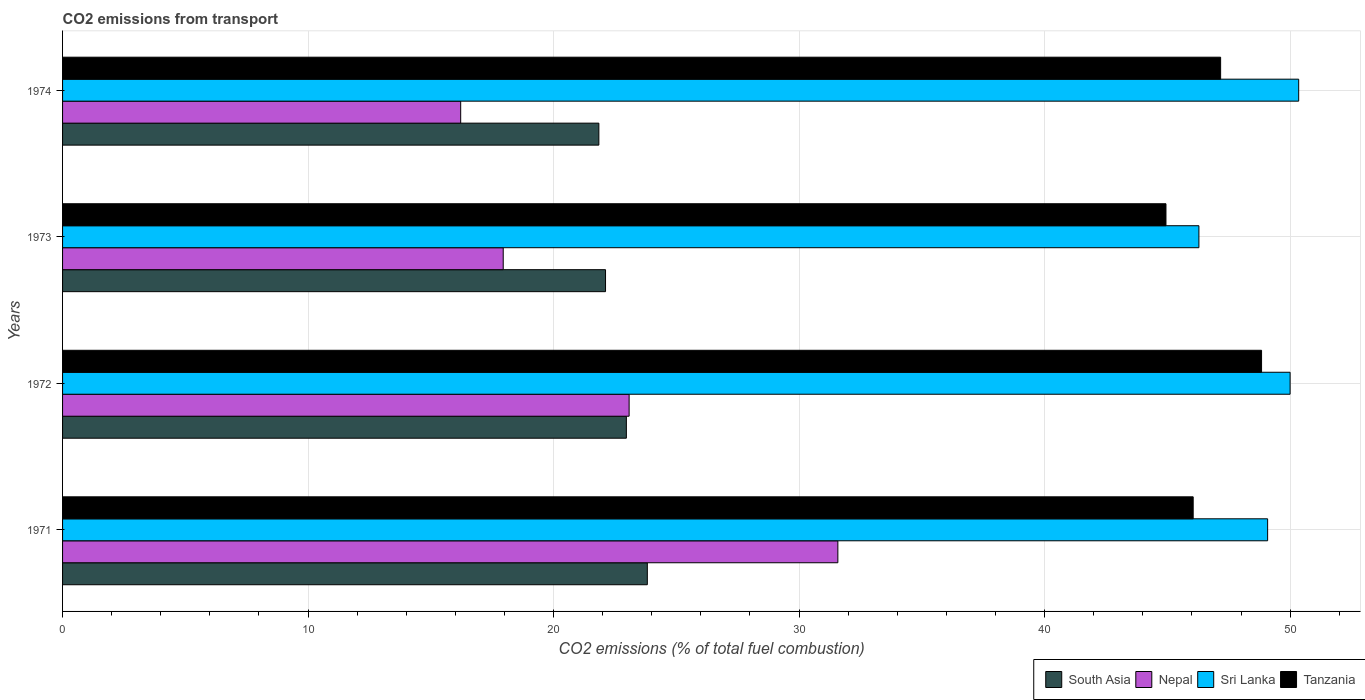How many different coloured bars are there?
Your answer should be very brief. 4. How many bars are there on the 2nd tick from the top?
Provide a succinct answer. 4. What is the label of the 4th group of bars from the top?
Offer a very short reply. 1971. In how many cases, is the number of bars for a given year not equal to the number of legend labels?
Provide a short and direct response. 0. What is the total CO2 emitted in South Asia in 1971?
Keep it short and to the point. 23.82. Across all years, what is the maximum total CO2 emitted in South Asia?
Provide a short and direct response. 23.82. Across all years, what is the minimum total CO2 emitted in South Asia?
Give a very brief answer. 21.84. In which year was the total CO2 emitted in South Asia minimum?
Keep it short and to the point. 1974. What is the total total CO2 emitted in Nepal in the graph?
Make the answer very short. 88.82. What is the difference between the total CO2 emitted in Nepal in 1972 and that in 1974?
Provide a short and direct response. 6.86. What is the difference between the total CO2 emitted in South Asia in 1973 and the total CO2 emitted in Tanzania in 1972?
Provide a short and direct response. -26.72. What is the average total CO2 emitted in Sri Lanka per year?
Offer a terse response. 48.93. In the year 1971, what is the difference between the total CO2 emitted in Tanzania and total CO2 emitted in Nepal?
Give a very brief answer. 14.47. What is the ratio of the total CO2 emitted in Sri Lanka in 1972 to that in 1973?
Keep it short and to the point. 1.08. Is the difference between the total CO2 emitted in Tanzania in 1973 and 1974 greater than the difference between the total CO2 emitted in Nepal in 1973 and 1974?
Ensure brevity in your answer.  No. What is the difference between the highest and the second highest total CO2 emitted in Tanzania?
Keep it short and to the point. 1.67. What is the difference between the highest and the lowest total CO2 emitted in South Asia?
Offer a very short reply. 1.97. Is the sum of the total CO2 emitted in Nepal in 1971 and 1974 greater than the maximum total CO2 emitted in Sri Lanka across all years?
Your answer should be very brief. No. What does the 3rd bar from the bottom in 1972 represents?
Offer a terse response. Sri Lanka. Is it the case that in every year, the sum of the total CO2 emitted in South Asia and total CO2 emitted in Tanzania is greater than the total CO2 emitted in Nepal?
Ensure brevity in your answer.  Yes. How many bars are there?
Provide a succinct answer. 16. Are all the bars in the graph horizontal?
Offer a terse response. Yes. Are the values on the major ticks of X-axis written in scientific E-notation?
Offer a very short reply. No. Where does the legend appear in the graph?
Your response must be concise. Bottom right. How many legend labels are there?
Your answer should be very brief. 4. How are the legend labels stacked?
Ensure brevity in your answer.  Horizontal. What is the title of the graph?
Offer a terse response. CO2 emissions from transport. What is the label or title of the X-axis?
Keep it short and to the point. CO2 emissions (% of total fuel combustion). What is the label or title of the Y-axis?
Provide a short and direct response. Years. What is the CO2 emissions (% of total fuel combustion) in South Asia in 1971?
Give a very brief answer. 23.82. What is the CO2 emissions (% of total fuel combustion) in Nepal in 1971?
Your response must be concise. 31.58. What is the CO2 emissions (% of total fuel combustion) of Sri Lanka in 1971?
Your response must be concise. 49.08. What is the CO2 emissions (% of total fuel combustion) of Tanzania in 1971?
Ensure brevity in your answer.  46.05. What is the CO2 emissions (% of total fuel combustion) in South Asia in 1972?
Your answer should be very brief. 22.96. What is the CO2 emissions (% of total fuel combustion) of Nepal in 1972?
Your response must be concise. 23.08. What is the CO2 emissions (% of total fuel combustion) of Sri Lanka in 1972?
Ensure brevity in your answer.  50. What is the CO2 emissions (% of total fuel combustion) in Tanzania in 1972?
Make the answer very short. 48.84. What is the CO2 emissions (% of total fuel combustion) in South Asia in 1973?
Your answer should be very brief. 22.12. What is the CO2 emissions (% of total fuel combustion) of Nepal in 1973?
Provide a short and direct response. 17.95. What is the CO2 emissions (% of total fuel combustion) in Sri Lanka in 1973?
Your response must be concise. 46.29. What is the CO2 emissions (% of total fuel combustion) of Tanzania in 1973?
Offer a terse response. 44.94. What is the CO2 emissions (% of total fuel combustion) in South Asia in 1974?
Offer a terse response. 21.84. What is the CO2 emissions (% of total fuel combustion) in Nepal in 1974?
Your answer should be compact. 16.22. What is the CO2 emissions (% of total fuel combustion) in Sri Lanka in 1974?
Make the answer very short. 50.35. What is the CO2 emissions (% of total fuel combustion) in Tanzania in 1974?
Give a very brief answer. 47.17. Across all years, what is the maximum CO2 emissions (% of total fuel combustion) in South Asia?
Provide a short and direct response. 23.82. Across all years, what is the maximum CO2 emissions (% of total fuel combustion) of Nepal?
Provide a short and direct response. 31.58. Across all years, what is the maximum CO2 emissions (% of total fuel combustion) in Sri Lanka?
Provide a succinct answer. 50.35. Across all years, what is the maximum CO2 emissions (% of total fuel combustion) of Tanzania?
Offer a very short reply. 48.84. Across all years, what is the minimum CO2 emissions (% of total fuel combustion) in South Asia?
Make the answer very short. 21.84. Across all years, what is the minimum CO2 emissions (% of total fuel combustion) of Nepal?
Offer a very short reply. 16.22. Across all years, what is the minimum CO2 emissions (% of total fuel combustion) in Sri Lanka?
Provide a short and direct response. 46.29. Across all years, what is the minimum CO2 emissions (% of total fuel combustion) of Tanzania?
Ensure brevity in your answer.  44.94. What is the total CO2 emissions (% of total fuel combustion) of South Asia in the graph?
Provide a short and direct response. 90.74. What is the total CO2 emissions (% of total fuel combustion) of Nepal in the graph?
Offer a very short reply. 88.82. What is the total CO2 emissions (% of total fuel combustion) of Sri Lanka in the graph?
Your answer should be very brief. 195.72. What is the total CO2 emissions (% of total fuel combustion) of Tanzania in the graph?
Offer a terse response. 187. What is the difference between the CO2 emissions (% of total fuel combustion) of South Asia in 1971 and that in 1972?
Keep it short and to the point. 0.85. What is the difference between the CO2 emissions (% of total fuel combustion) of Nepal in 1971 and that in 1972?
Your answer should be very brief. 8.5. What is the difference between the CO2 emissions (% of total fuel combustion) of Sri Lanka in 1971 and that in 1972?
Give a very brief answer. -0.92. What is the difference between the CO2 emissions (% of total fuel combustion) in Tanzania in 1971 and that in 1972?
Provide a short and direct response. -2.78. What is the difference between the CO2 emissions (% of total fuel combustion) in South Asia in 1971 and that in 1973?
Your answer should be very brief. 1.7. What is the difference between the CO2 emissions (% of total fuel combustion) of Nepal in 1971 and that in 1973?
Offer a terse response. 13.63. What is the difference between the CO2 emissions (% of total fuel combustion) in Sri Lanka in 1971 and that in 1973?
Your answer should be compact. 2.8. What is the difference between the CO2 emissions (% of total fuel combustion) in Tanzania in 1971 and that in 1973?
Offer a terse response. 1.11. What is the difference between the CO2 emissions (% of total fuel combustion) of South Asia in 1971 and that in 1974?
Your response must be concise. 1.97. What is the difference between the CO2 emissions (% of total fuel combustion) in Nepal in 1971 and that in 1974?
Your answer should be very brief. 15.36. What is the difference between the CO2 emissions (% of total fuel combustion) in Sri Lanka in 1971 and that in 1974?
Provide a succinct answer. -1.27. What is the difference between the CO2 emissions (% of total fuel combustion) of Tanzania in 1971 and that in 1974?
Your answer should be very brief. -1.12. What is the difference between the CO2 emissions (% of total fuel combustion) of South Asia in 1972 and that in 1973?
Offer a terse response. 0.85. What is the difference between the CO2 emissions (% of total fuel combustion) of Nepal in 1972 and that in 1973?
Keep it short and to the point. 5.13. What is the difference between the CO2 emissions (% of total fuel combustion) of Sri Lanka in 1972 and that in 1973?
Give a very brief answer. 3.71. What is the difference between the CO2 emissions (% of total fuel combustion) in Tanzania in 1972 and that in 1973?
Offer a very short reply. 3.89. What is the difference between the CO2 emissions (% of total fuel combustion) of South Asia in 1972 and that in 1974?
Provide a short and direct response. 1.12. What is the difference between the CO2 emissions (% of total fuel combustion) in Nepal in 1972 and that in 1974?
Your response must be concise. 6.86. What is the difference between the CO2 emissions (% of total fuel combustion) of Sri Lanka in 1972 and that in 1974?
Make the answer very short. -0.35. What is the difference between the CO2 emissions (% of total fuel combustion) of Tanzania in 1972 and that in 1974?
Offer a terse response. 1.67. What is the difference between the CO2 emissions (% of total fuel combustion) in South Asia in 1973 and that in 1974?
Make the answer very short. 0.27. What is the difference between the CO2 emissions (% of total fuel combustion) of Nepal in 1973 and that in 1974?
Keep it short and to the point. 1.73. What is the difference between the CO2 emissions (% of total fuel combustion) of Sri Lanka in 1973 and that in 1974?
Your answer should be very brief. -4.06. What is the difference between the CO2 emissions (% of total fuel combustion) in Tanzania in 1973 and that in 1974?
Offer a very short reply. -2.23. What is the difference between the CO2 emissions (% of total fuel combustion) of South Asia in 1971 and the CO2 emissions (% of total fuel combustion) of Nepal in 1972?
Your answer should be very brief. 0.74. What is the difference between the CO2 emissions (% of total fuel combustion) of South Asia in 1971 and the CO2 emissions (% of total fuel combustion) of Sri Lanka in 1972?
Keep it short and to the point. -26.18. What is the difference between the CO2 emissions (% of total fuel combustion) in South Asia in 1971 and the CO2 emissions (% of total fuel combustion) in Tanzania in 1972?
Your response must be concise. -25.02. What is the difference between the CO2 emissions (% of total fuel combustion) in Nepal in 1971 and the CO2 emissions (% of total fuel combustion) in Sri Lanka in 1972?
Your response must be concise. -18.42. What is the difference between the CO2 emissions (% of total fuel combustion) in Nepal in 1971 and the CO2 emissions (% of total fuel combustion) in Tanzania in 1972?
Keep it short and to the point. -17.26. What is the difference between the CO2 emissions (% of total fuel combustion) in Sri Lanka in 1971 and the CO2 emissions (% of total fuel combustion) in Tanzania in 1972?
Give a very brief answer. 0.25. What is the difference between the CO2 emissions (% of total fuel combustion) in South Asia in 1971 and the CO2 emissions (% of total fuel combustion) in Nepal in 1973?
Your answer should be very brief. 5.87. What is the difference between the CO2 emissions (% of total fuel combustion) of South Asia in 1971 and the CO2 emissions (% of total fuel combustion) of Sri Lanka in 1973?
Give a very brief answer. -22.47. What is the difference between the CO2 emissions (% of total fuel combustion) of South Asia in 1971 and the CO2 emissions (% of total fuel combustion) of Tanzania in 1973?
Make the answer very short. -21.13. What is the difference between the CO2 emissions (% of total fuel combustion) of Nepal in 1971 and the CO2 emissions (% of total fuel combustion) of Sri Lanka in 1973?
Make the answer very short. -14.71. What is the difference between the CO2 emissions (% of total fuel combustion) in Nepal in 1971 and the CO2 emissions (% of total fuel combustion) in Tanzania in 1973?
Offer a very short reply. -13.36. What is the difference between the CO2 emissions (% of total fuel combustion) in Sri Lanka in 1971 and the CO2 emissions (% of total fuel combustion) in Tanzania in 1973?
Offer a terse response. 4.14. What is the difference between the CO2 emissions (% of total fuel combustion) of South Asia in 1971 and the CO2 emissions (% of total fuel combustion) of Nepal in 1974?
Your response must be concise. 7.6. What is the difference between the CO2 emissions (% of total fuel combustion) of South Asia in 1971 and the CO2 emissions (% of total fuel combustion) of Sri Lanka in 1974?
Your response must be concise. -26.53. What is the difference between the CO2 emissions (% of total fuel combustion) of South Asia in 1971 and the CO2 emissions (% of total fuel combustion) of Tanzania in 1974?
Ensure brevity in your answer.  -23.35. What is the difference between the CO2 emissions (% of total fuel combustion) of Nepal in 1971 and the CO2 emissions (% of total fuel combustion) of Sri Lanka in 1974?
Provide a short and direct response. -18.77. What is the difference between the CO2 emissions (% of total fuel combustion) of Nepal in 1971 and the CO2 emissions (% of total fuel combustion) of Tanzania in 1974?
Provide a succinct answer. -15.59. What is the difference between the CO2 emissions (% of total fuel combustion) in Sri Lanka in 1971 and the CO2 emissions (% of total fuel combustion) in Tanzania in 1974?
Provide a short and direct response. 1.91. What is the difference between the CO2 emissions (% of total fuel combustion) in South Asia in 1972 and the CO2 emissions (% of total fuel combustion) in Nepal in 1973?
Your answer should be very brief. 5.02. What is the difference between the CO2 emissions (% of total fuel combustion) in South Asia in 1972 and the CO2 emissions (% of total fuel combustion) in Sri Lanka in 1973?
Your answer should be very brief. -23.32. What is the difference between the CO2 emissions (% of total fuel combustion) of South Asia in 1972 and the CO2 emissions (% of total fuel combustion) of Tanzania in 1973?
Provide a succinct answer. -21.98. What is the difference between the CO2 emissions (% of total fuel combustion) of Nepal in 1972 and the CO2 emissions (% of total fuel combustion) of Sri Lanka in 1973?
Keep it short and to the point. -23.21. What is the difference between the CO2 emissions (% of total fuel combustion) of Nepal in 1972 and the CO2 emissions (% of total fuel combustion) of Tanzania in 1973?
Ensure brevity in your answer.  -21.87. What is the difference between the CO2 emissions (% of total fuel combustion) of Sri Lanka in 1972 and the CO2 emissions (% of total fuel combustion) of Tanzania in 1973?
Provide a short and direct response. 5.06. What is the difference between the CO2 emissions (% of total fuel combustion) in South Asia in 1972 and the CO2 emissions (% of total fuel combustion) in Nepal in 1974?
Your answer should be compact. 6.75. What is the difference between the CO2 emissions (% of total fuel combustion) in South Asia in 1972 and the CO2 emissions (% of total fuel combustion) in Sri Lanka in 1974?
Give a very brief answer. -27.39. What is the difference between the CO2 emissions (% of total fuel combustion) in South Asia in 1972 and the CO2 emissions (% of total fuel combustion) in Tanzania in 1974?
Make the answer very short. -24.21. What is the difference between the CO2 emissions (% of total fuel combustion) of Nepal in 1972 and the CO2 emissions (% of total fuel combustion) of Sri Lanka in 1974?
Ensure brevity in your answer.  -27.27. What is the difference between the CO2 emissions (% of total fuel combustion) of Nepal in 1972 and the CO2 emissions (% of total fuel combustion) of Tanzania in 1974?
Make the answer very short. -24.09. What is the difference between the CO2 emissions (% of total fuel combustion) of Sri Lanka in 1972 and the CO2 emissions (% of total fuel combustion) of Tanzania in 1974?
Your answer should be compact. 2.83. What is the difference between the CO2 emissions (% of total fuel combustion) of South Asia in 1973 and the CO2 emissions (% of total fuel combustion) of Nepal in 1974?
Offer a very short reply. 5.9. What is the difference between the CO2 emissions (% of total fuel combustion) of South Asia in 1973 and the CO2 emissions (% of total fuel combustion) of Sri Lanka in 1974?
Give a very brief answer. -28.23. What is the difference between the CO2 emissions (% of total fuel combustion) of South Asia in 1973 and the CO2 emissions (% of total fuel combustion) of Tanzania in 1974?
Offer a very short reply. -25.05. What is the difference between the CO2 emissions (% of total fuel combustion) in Nepal in 1973 and the CO2 emissions (% of total fuel combustion) in Sri Lanka in 1974?
Offer a very short reply. -32.4. What is the difference between the CO2 emissions (% of total fuel combustion) in Nepal in 1973 and the CO2 emissions (% of total fuel combustion) in Tanzania in 1974?
Your answer should be very brief. -29.22. What is the difference between the CO2 emissions (% of total fuel combustion) in Sri Lanka in 1973 and the CO2 emissions (% of total fuel combustion) in Tanzania in 1974?
Offer a terse response. -0.88. What is the average CO2 emissions (% of total fuel combustion) in South Asia per year?
Give a very brief answer. 22.69. What is the average CO2 emissions (% of total fuel combustion) of Nepal per year?
Your answer should be very brief. 22.21. What is the average CO2 emissions (% of total fuel combustion) of Sri Lanka per year?
Offer a very short reply. 48.93. What is the average CO2 emissions (% of total fuel combustion) in Tanzania per year?
Make the answer very short. 46.75. In the year 1971, what is the difference between the CO2 emissions (% of total fuel combustion) in South Asia and CO2 emissions (% of total fuel combustion) in Nepal?
Keep it short and to the point. -7.76. In the year 1971, what is the difference between the CO2 emissions (% of total fuel combustion) in South Asia and CO2 emissions (% of total fuel combustion) in Sri Lanka?
Make the answer very short. -25.27. In the year 1971, what is the difference between the CO2 emissions (% of total fuel combustion) of South Asia and CO2 emissions (% of total fuel combustion) of Tanzania?
Your answer should be compact. -22.23. In the year 1971, what is the difference between the CO2 emissions (% of total fuel combustion) of Nepal and CO2 emissions (% of total fuel combustion) of Sri Lanka?
Your answer should be compact. -17.51. In the year 1971, what is the difference between the CO2 emissions (% of total fuel combustion) of Nepal and CO2 emissions (% of total fuel combustion) of Tanzania?
Provide a succinct answer. -14.47. In the year 1971, what is the difference between the CO2 emissions (% of total fuel combustion) of Sri Lanka and CO2 emissions (% of total fuel combustion) of Tanzania?
Provide a succinct answer. 3.03. In the year 1972, what is the difference between the CO2 emissions (% of total fuel combustion) in South Asia and CO2 emissions (% of total fuel combustion) in Nepal?
Provide a short and direct response. -0.11. In the year 1972, what is the difference between the CO2 emissions (% of total fuel combustion) of South Asia and CO2 emissions (% of total fuel combustion) of Sri Lanka?
Your response must be concise. -27.04. In the year 1972, what is the difference between the CO2 emissions (% of total fuel combustion) in South Asia and CO2 emissions (% of total fuel combustion) in Tanzania?
Your answer should be compact. -25.87. In the year 1972, what is the difference between the CO2 emissions (% of total fuel combustion) of Nepal and CO2 emissions (% of total fuel combustion) of Sri Lanka?
Provide a succinct answer. -26.92. In the year 1972, what is the difference between the CO2 emissions (% of total fuel combustion) of Nepal and CO2 emissions (% of total fuel combustion) of Tanzania?
Give a very brief answer. -25.76. In the year 1972, what is the difference between the CO2 emissions (% of total fuel combustion) in Sri Lanka and CO2 emissions (% of total fuel combustion) in Tanzania?
Offer a terse response. 1.16. In the year 1973, what is the difference between the CO2 emissions (% of total fuel combustion) of South Asia and CO2 emissions (% of total fuel combustion) of Nepal?
Give a very brief answer. 4.17. In the year 1973, what is the difference between the CO2 emissions (% of total fuel combustion) in South Asia and CO2 emissions (% of total fuel combustion) in Sri Lanka?
Offer a very short reply. -24.17. In the year 1973, what is the difference between the CO2 emissions (% of total fuel combustion) in South Asia and CO2 emissions (% of total fuel combustion) in Tanzania?
Your response must be concise. -22.83. In the year 1973, what is the difference between the CO2 emissions (% of total fuel combustion) in Nepal and CO2 emissions (% of total fuel combustion) in Sri Lanka?
Provide a short and direct response. -28.34. In the year 1973, what is the difference between the CO2 emissions (% of total fuel combustion) in Nepal and CO2 emissions (% of total fuel combustion) in Tanzania?
Your answer should be very brief. -27. In the year 1973, what is the difference between the CO2 emissions (% of total fuel combustion) in Sri Lanka and CO2 emissions (% of total fuel combustion) in Tanzania?
Keep it short and to the point. 1.34. In the year 1974, what is the difference between the CO2 emissions (% of total fuel combustion) of South Asia and CO2 emissions (% of total fuel combustion) of Nepal?
Offer a very short reply. 5.63. In the year 1974, what is the difference between the CO2 emissions (% of total fuel combustion) in South Asia and CO2 emissions (% of total fuel combustion) in Sri Lanka?
Offer a very short reply. -28.51. In the year 1974, what is the difference between the CO2 emissions (% of total fuel combustion) in South Asia and CO2 emissions (% of total fuel combustion) in Tanzania?
Keep it short and to the point. -25.33. In the year 1974, what is the difference between the CO2 emissions (% of total fuel combustion) in Nepal and CO2 emissions (% of total fuel combustion) in Sri Lanka?
Your answer should be compact. -34.13. In the year 1974, what is the difference between the CO2 emissions (% of total fuel combustion) in Nepal and CO2 emissions (% of total fuel combustion) in Tanzania?
Ensure brevity in your answer.  -30.95. In the year 1974, what is the difference between the CO2 emissions (% of total fuel combustion) of Sri Lanka and CO2 emissions (% of total fuel combustion) of Tanzania?
Your response must be concise. 3.18. What is the ratio of the CO2 emissions (% of total fuel combustion) in South Asia in 1971 to that in 1972?
Your answer should be very brief. 1.04. What is the ratio of the CO2 emissions (% of total fuel combustion) in Nepal in 1971 to that in 1972?
Keep it short and to the point. 1.37. What is the ratio of the CO2 emissions (% of total fuel combustion) of Sri Lanka in 1971 to that in 1972?
Provide a short and direct response. 0.98. What is the ratio of the CO2 emissions (% of total fuel combustion) in Tanzania in 1971 to that in 1972?
Offer a terse response. 0.94. What is the ratio of the CO2 emissions (% of total fuel combustion) of South Asia in 1971 to that in 1973?
Your answer should be very brief. 1.08. What is the ratio of the CO2 emissions (% of total fuel combustion) in Nepal in 1971 to that in 1973?
Keep it short and to the point. 1.76. What is the ratio of the CO2 emissions (% of total fuel combustion) of Sri Lanka in 1971 to that in 1973?
Offer a terse response. 1.06. What is the ratio of the CO2 emissions (% of total fuel combustion) in Tanzania in 1971 to that in 1973?
Give a very brief answer. 1.02. What is the ratio of the CO2 emissions (% of total fuel combustion) in South Asia in 1971 to that in 1974?
Your response must be concise. 1.09. What is the ratio of the CO2 emissions (% of total fuel combustion) in Nepal in 1971 to that in 1974?
Give a very brief answer. 1.95. What is the ratio of the CO2 emissions (% of total fuel combustion) of Sri Lanka in 1971 to that in 1974?
Offer a terse response. 0.97. What is the ratio of the CO2 emissions (% of total fuel combustion) in Tanzania in 1971 to that in 1974?
Your answer should be very brief. 0.98. What is the ratio of the CO2 emissions (% of total fuel combustion) in South Asia in 1972 to that in 1973?
Offer a very short reply. 1.04. What is the ratio of the CO2 emissions (% of total fuel combustion) in Nepal in 1972 to that in 1973?
Make the answer very short. 1.29. What is the ratio of the CO2 emissions (% of total fuel combustion) of Sri Lanka in 1972 to that in 1973?
Give a very brief answer. 1.08. What is the ratio of the CO2 emissions (% of total fuel combustion) of Tanzania in 1972 to that in 1973?
Ensure brevity in your answer.  1.09. What is the ratio of the CO2 emissions (% of total fuel combustion) in South Asia in 1972 to that in 1974?
Make the answer very short. 1.05. What is the ratio of the CO2 emissions (% of total fuel combustion) in Nepal in 1972 to that in 1974?
Your answer should be compact. 1.42. What is the ratio of the CO2 emissions (% of total fuel combustion) of Tanzania in 1972 to that in 1974?
Provide a succinct answer. 1.04. What is the ratio of the CO2 emissions (% of total fuel combustion) of South Asia in 1973 to that in 1974?
Keep it short and to the point. 1.01. What is the ratio of the CO2 emissions (% of total fuel combustion) in Nepal in 1973 to that in 1974?
Your answer should be very brief. 1.11. What is the ratio of the CO2 emissions (% of total fuel combustion) of Sri Lanka in 1973 to that in 1974?
Make the answer very short. 0.92. What is the ratio of the CO2 emissions (% of total fuel combustion) in Tanzania in 1973 to that in 1974?
Your response must be concise. 0.95. What is the difference between the highest and the second highest CO2 emissions (% of total fuel combustion) in South Asia?
Keep it short and to the point. 0.85. What is the difference between the highest and the second highest CO2 emissions (% of total fuel combustion) of Nepal?
Your answer should be compact. 8.5. What is the difference between the highest and the second highest CO2 emissions (% of total fuel combustion) in Sri Lanka?
Make the answer very short. 0.35. What is the difference between the highest and the second highest CO2 emissions (% of total fuel combustion) of Tanzania?
Your response must be concise. 1.67. What is the difference between the highest and the lowest CO2 emissions (% of total fuel combustion) of South Asia?
Your response must be concise. 1.97. What is the difference between the highest and the lowest CO2 emissions (% of total fuel combustion) in Nepal?
Keep it short and to the point. 15.36. What is the difference between the highest and the lowest CO2 emissions (% of total fuel combustion) in Sri Lanka?
Offer a very short reply. 4.06. What is the difference between the highest and the lowest CO2 emissions (% of total fuel combustion) of Tanzania?
Ensure brevity in your answer.  3.89. 